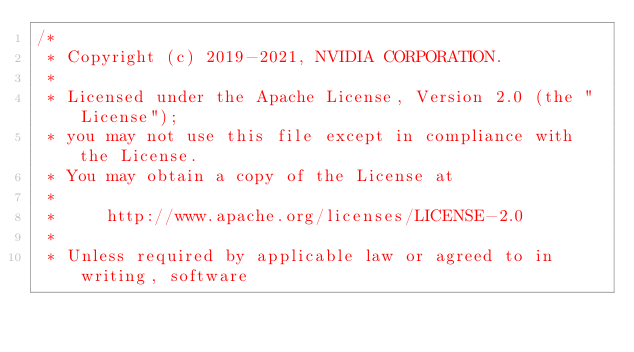Convert code to text. <code><loc_0><loc_0><loc_500><loc_500><_Cuda_>/*
 * Copyright (c) 2019-2021, NVIDIA CORPORATION.
 *
 * Licensed under the Apache License, Version 2.0 (the "License");
 * you may not use this file except in compliance with the License.
 * You may obtain a copy of the License at
 *
 *     http://www.apache.org/licenses/LICENSE-2.0
 *
 * Unless required by applicable law or agreed to in writing, software</code> 